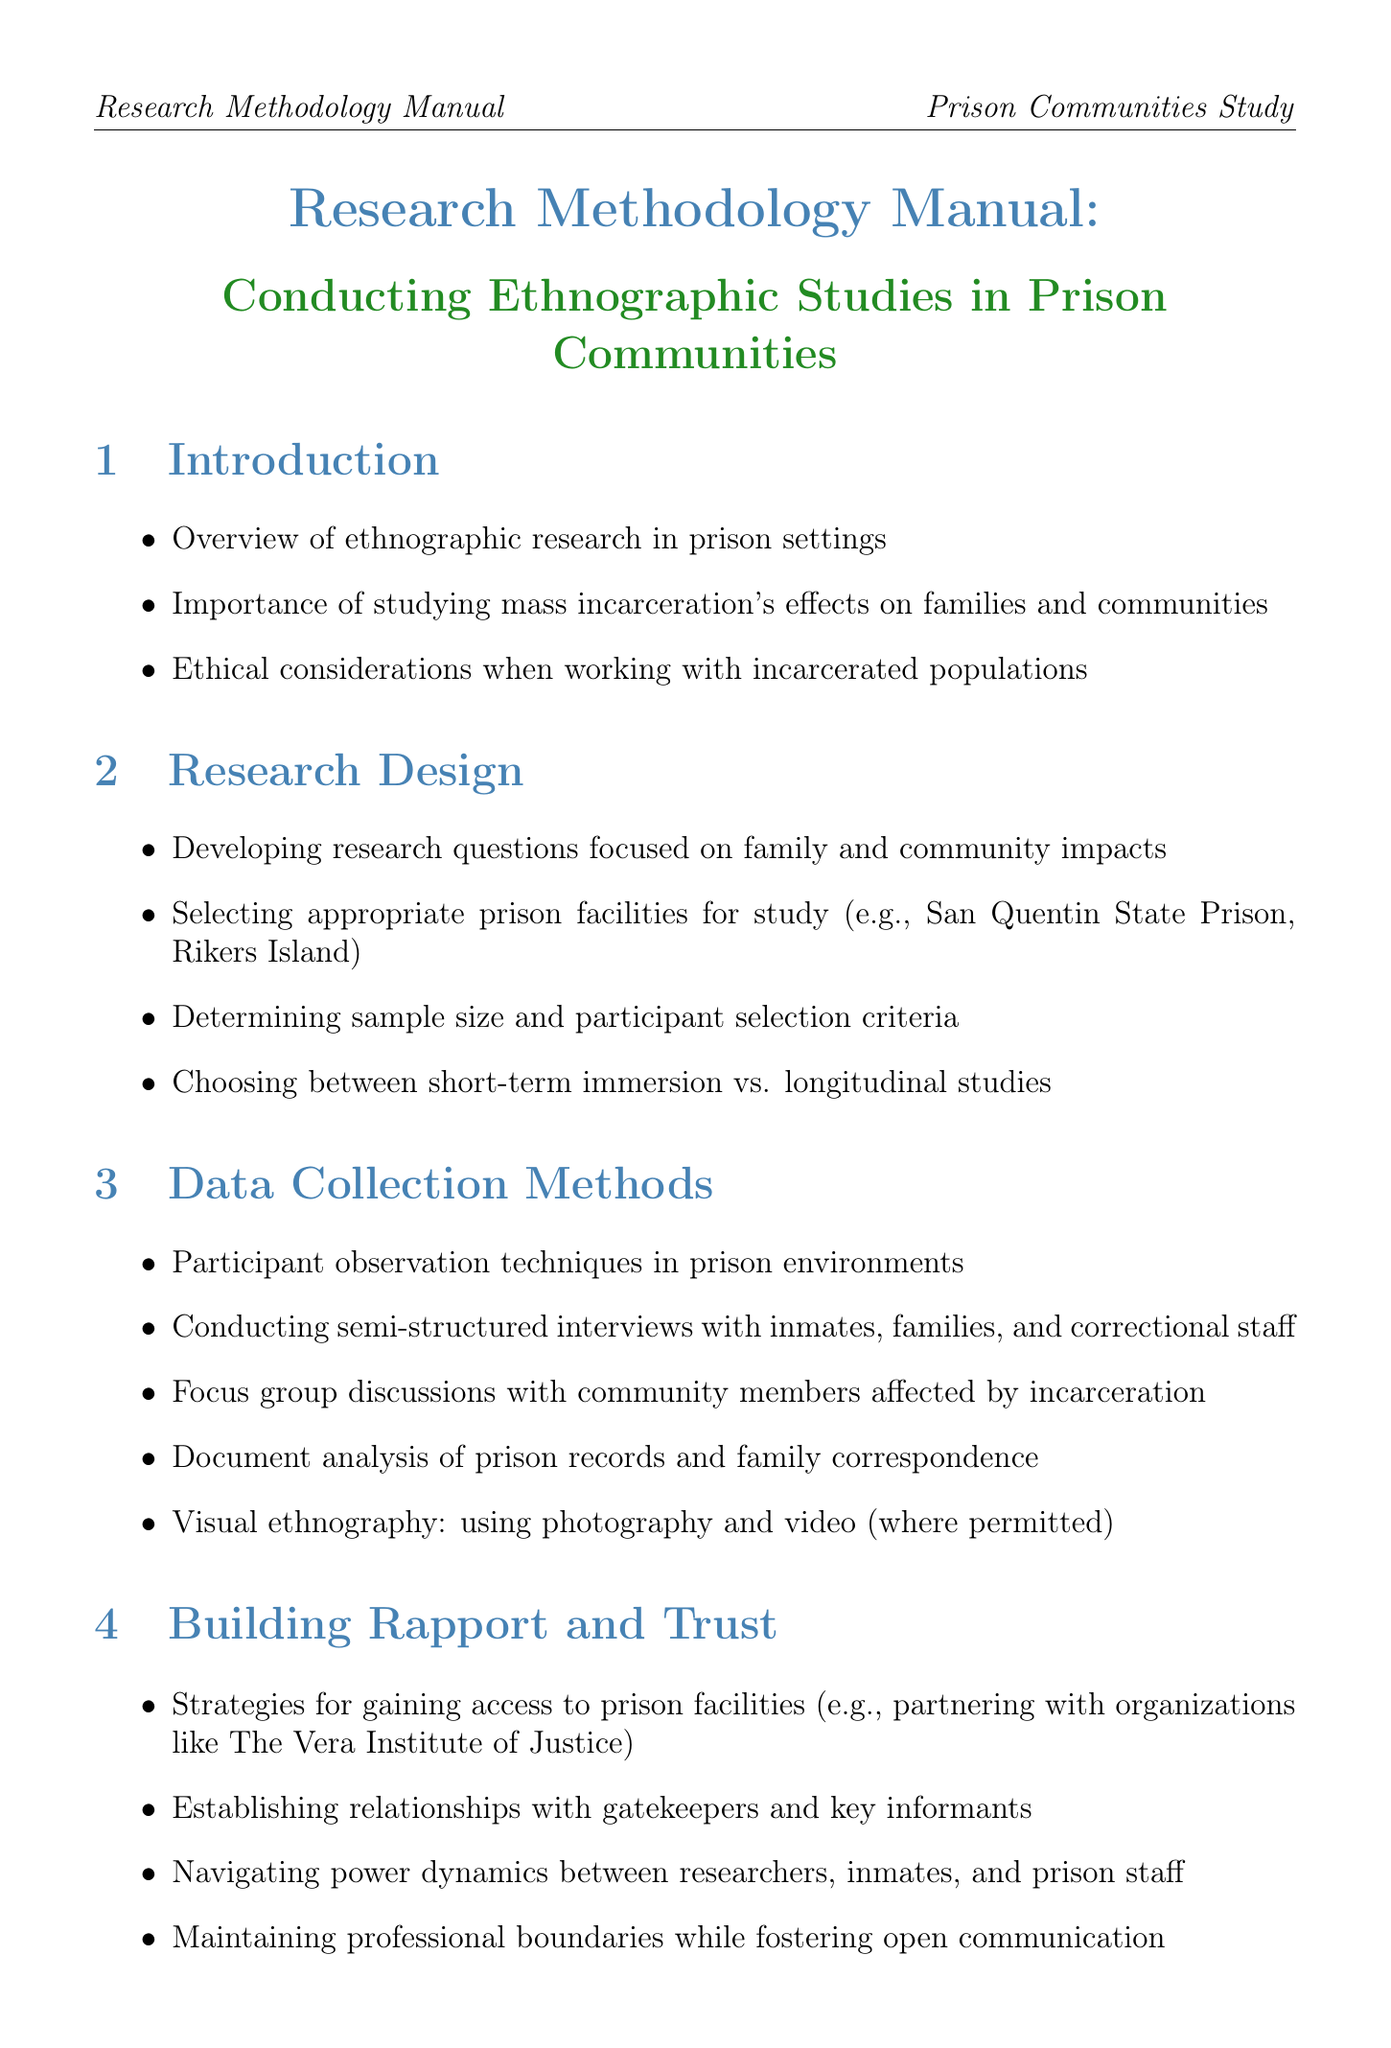What is the title of the manual? The title summarizing the document content and purpose is presented at the beginning of the document.
Answer: Research Methodology Manual: Conducting Ethnographic Studies in Prison Communities What is one example of a prison facility suggested for study? The document lists specific prison facilities as potential sites for conducting research in the prison community section.
Answer: San Quentin State Prison What type of data collection method includes community members? The methods listed in the data collection section include specific techniques for gathering insights from different stakeholders.
Answer: Focus group discussions What is a safety concern mentioned in the document? The manual highlights various concerns researchers should be aware of while conducting research in prisons, specifically related to safety and confidentiality.
Answer: Protecting participant confidentiality and anonymity Which qualitative data analysis software is mentioned? The document provides examples of tools researchers can use to analyze qualitative data gathered from their studies.
Answer: NVivo What is one ethical consideration outlined in the manual? The ethical considerations section emphasizes important aspects that researchers must address when working with vulnerable populations.
Answer: Obtaining informed consent from vulnerable populations What research design option is discussed? The research design section informs about various methodologies researchers can choose from depending on their specific study goals.
Answer: Longitudinal studies What is an example of a case study mentioned? The case studies section features specific studies conducted that are relevant to the research theme of the manual.
Answer: Ethnographic study of family visitation programs at Folsom State Prison What is one resource for further reading? The resources section provides suggested readings that complement the information provided in the manual and can enhance understanding of the subject.
Answer: "Doing Time Together: Love and Family in the Shadow of the Prison" by Megan Comfort 